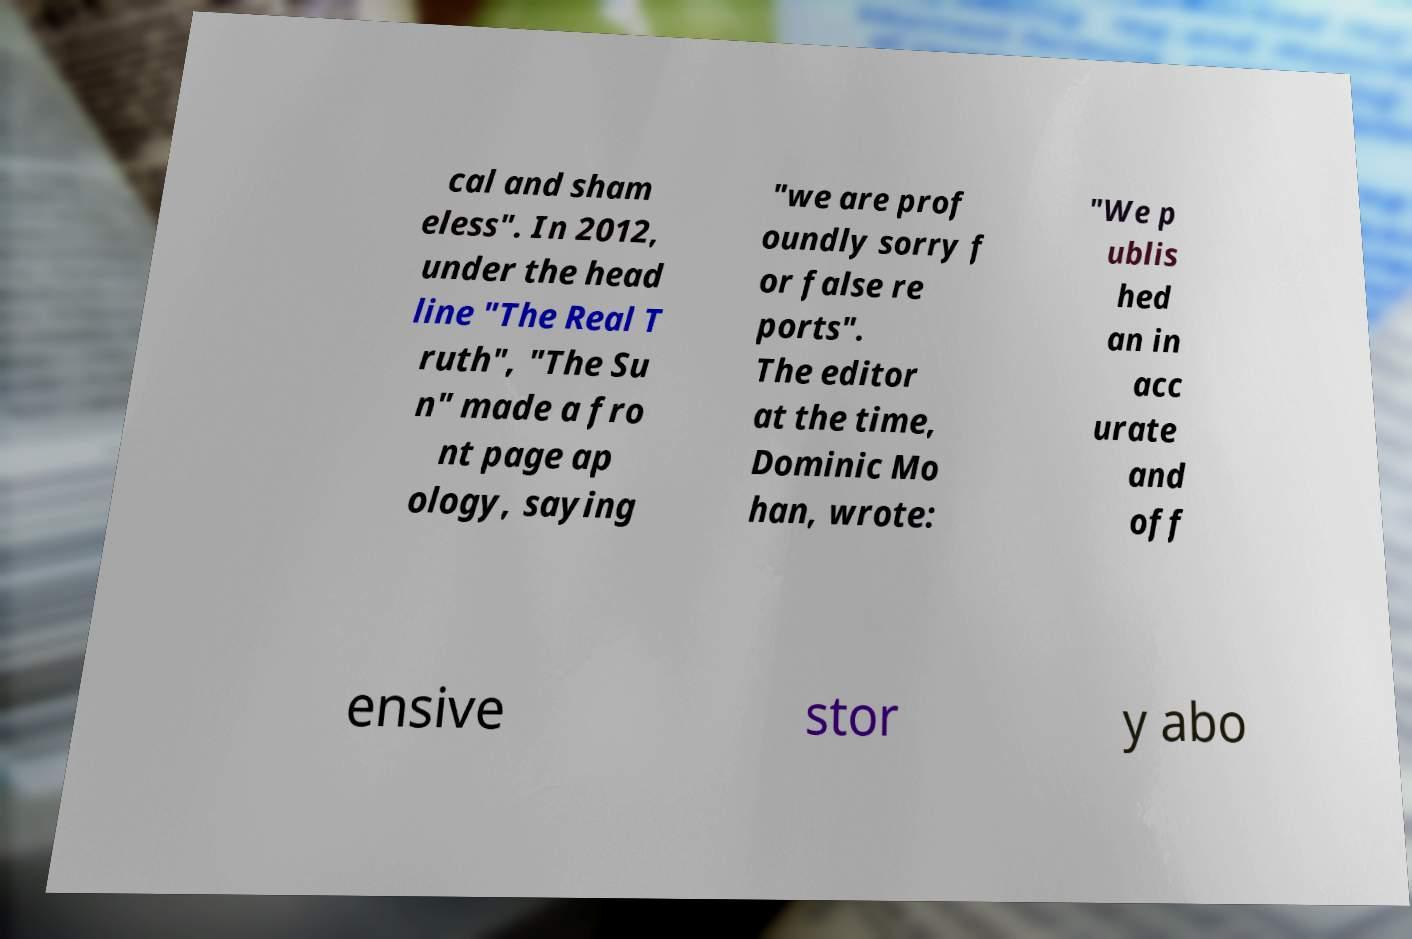Can you read and provide the text displayed in the image?This photo seems to have some interesting text. Can you extract and type it out for me? cal and sham eless". In 2012, under the head line "The Real T ruth", "The Su n" made a fro nt page ap ology, saying "we are prof oundly sorry f or false re ports". The editor at the time, Dominic Mo han, wrote: "We p ublis hed an in acc urate and off ensive stor y abo 